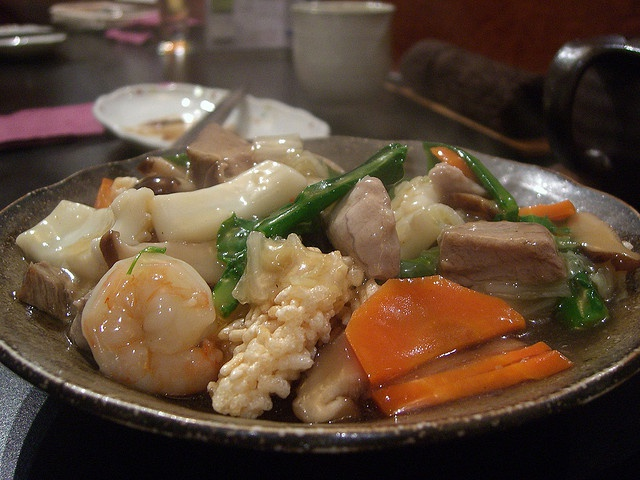Describe the objects in this image and their specific colors. I can see bowl in black, olive, brown, and tan tones, carrot in black, brown, and maroon tones, dining table in black and gray tones, cup in black and gray tones, and broccoli in black, darkgreen, and olive tones in this image. 